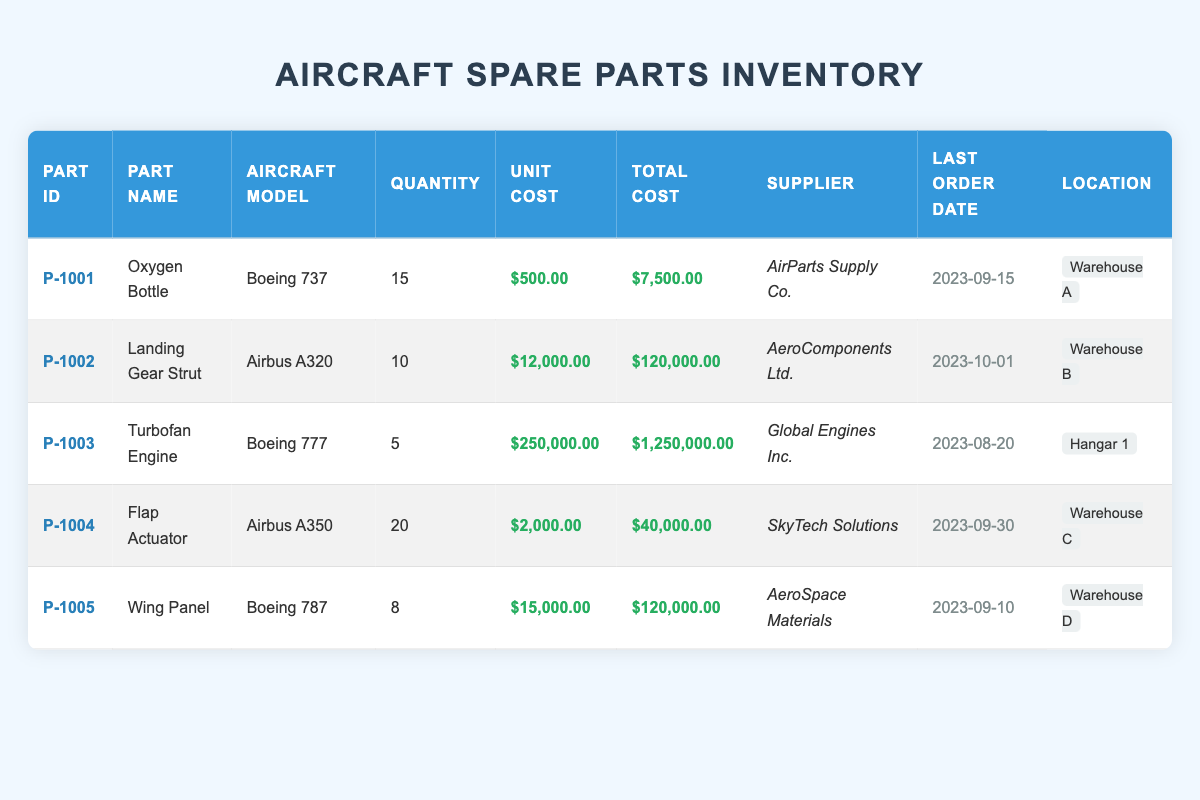What is the unit cost of the Oxygen Bottle? The unit cost of the Oxygen Bottle is listed in the table under the “Unit Cost” column for the part with ID P-1001. It clearly states $500.00.
Answer: 500.00 How many Turbofan Engines are currently in stock? By referring to the "Quantity" column for the part ID P-1003, it states there are 5 Turbofan Engines available in stock.
Answer: 5 Which part has the highest total cost? To identify the part with the highest total cost, I compare the “Total Cost” values. The Turbofan Engine has the highest total cost of $1,250,000.00.
Answer: Turbofan Engine Is there more than one part listed under the Airbus model? Looking at the "Aircraft Model" column, only one part, the Landing Gear Strut under the Airbus A320, meets the criteria, confirming that not more than one part is listed for the Airbus models.
Answer: No What is the total cost of all parts in inventory combined? Adding together the total costs from all parts involves calculating: $7,500.00 + $120,000.00 + $1,250,000.00 + $40,000.00 + $120,000.00 = $1,537,500.00.
Answer: 1,537,500.00 Which supplier provides the Flap Actuator? The Flap Actuator is associated with the supplier stated in the “Supplier” column for part ID P-1004, which is SkyTech Solutions.
Answer: SkyTech Solutions How many total parts are available for Boeing aircraft models? The table indicates three Boeing models: Oxygen Bottle (15 units), Turbofan Engine (5 units), and Wing Panel (8 units). Adding these gives a total of 15 + 5 + 8 = 28 parts for Boeing models.
Answer: 28 Is it true that the last order date for the Landing Gear Strut was in September 2023? The “Last Order Date” for the Landing Gear Strut, as seen in the table, is October 1, 2023, which means the statement is false.
Answer: No What is the average unit cost of all parts in the inventory? Calculating the average unit cost involves summing the unit costs: 500.00 + 12000.00 + 250000.00 + 2000.00 + 15000.00 = 279,500.00. Dividing this sum by the number of parts (5) gives $55,900.00 as the average unit cost.
Answer: 55,900.00 